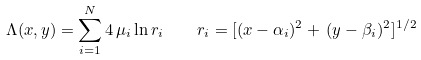<formula> <loc_0><loc_0><loc_500><loc_500>\Lambda ( x , y ) = \sum _ { i = 1 } ^ { N } 4 \, \mu _ { i } \ln r _ { i } \quad r _ { i } = [ ( x - \alpha _ { i } ) ^ { 2 } + \, ( y - \beta _ { i } ) ^ { 2 } ] ^ { 1 / 2 }</formula> 